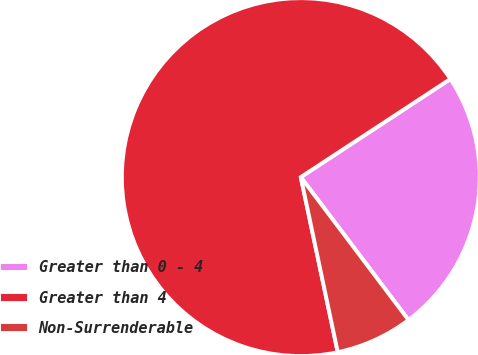Convert chart. <chart><loc_0><loc_0><loc_500><loc_500><pie_chart><fcel>Greater than 0 - 4<fcel>Greater than 4<fcel>Non-Surrenderable<nl><fcel>23.96%<fcel>69.07%<fcel>6.97%<nl></chart> 